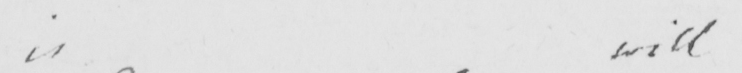What does this handwritten line say? is will 